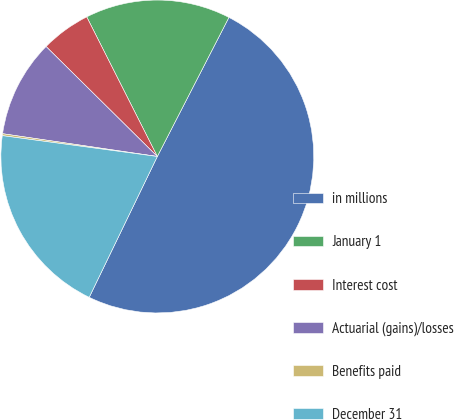Convert chart. <chart><loc_0><loc_0><loc_500><loc_500><pie_chart><fcel>in millions<fcel>January 1<fcel>Interest cost<fcel>Actuarial (gains)/losses<fcel>Benefits paid<fcel>December 31<nl><fcel>49.61%<fcel>15.02%<fcel>5.14%<fcel>10.08%<fcel>0.2%<fcel>19.96%<nl></chart> 